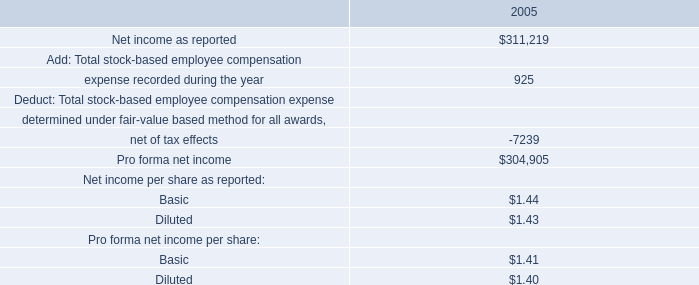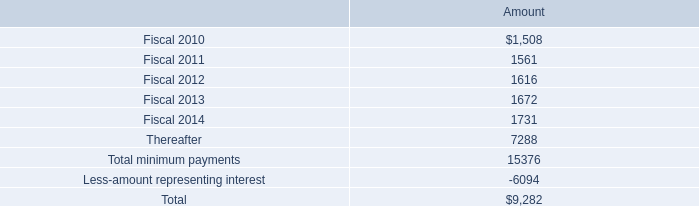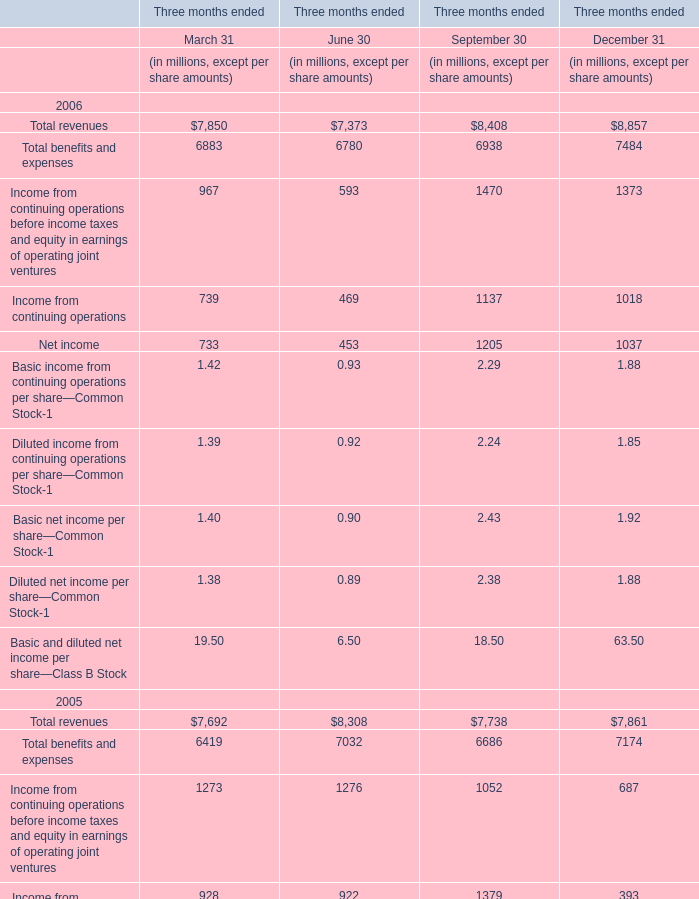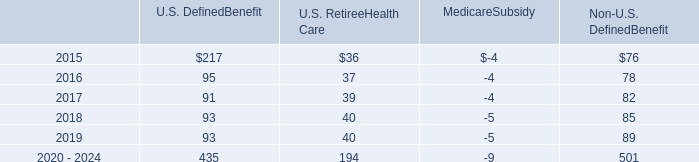What is the growing rate of net income in the year with the most total revenue in September 30? 
Computations: ((1205 - 1364) / 1364)
Answer: -0.11657. 